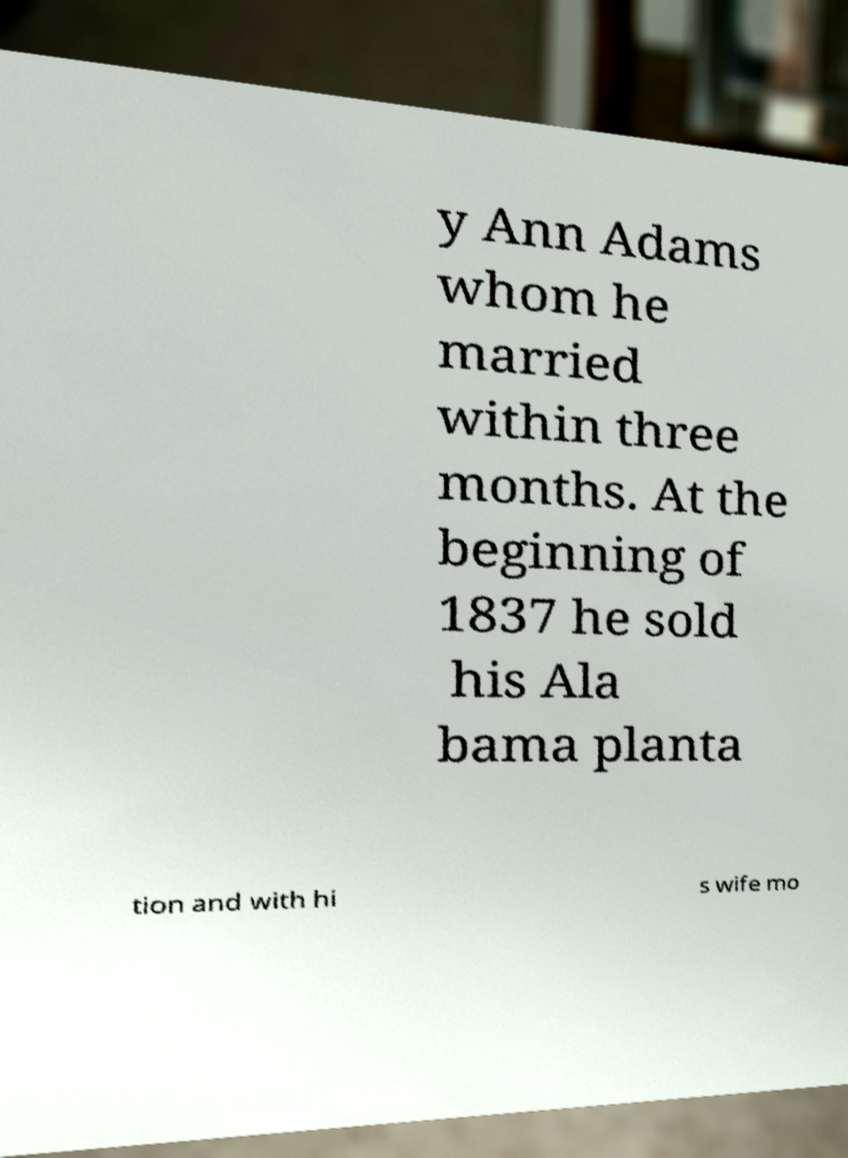Please identify and transcribe the text found in this image. y Ann Adams whom he married within three months. At the beginning of 1837 he sold his Ala bama planta tion and with hi s wife mo 